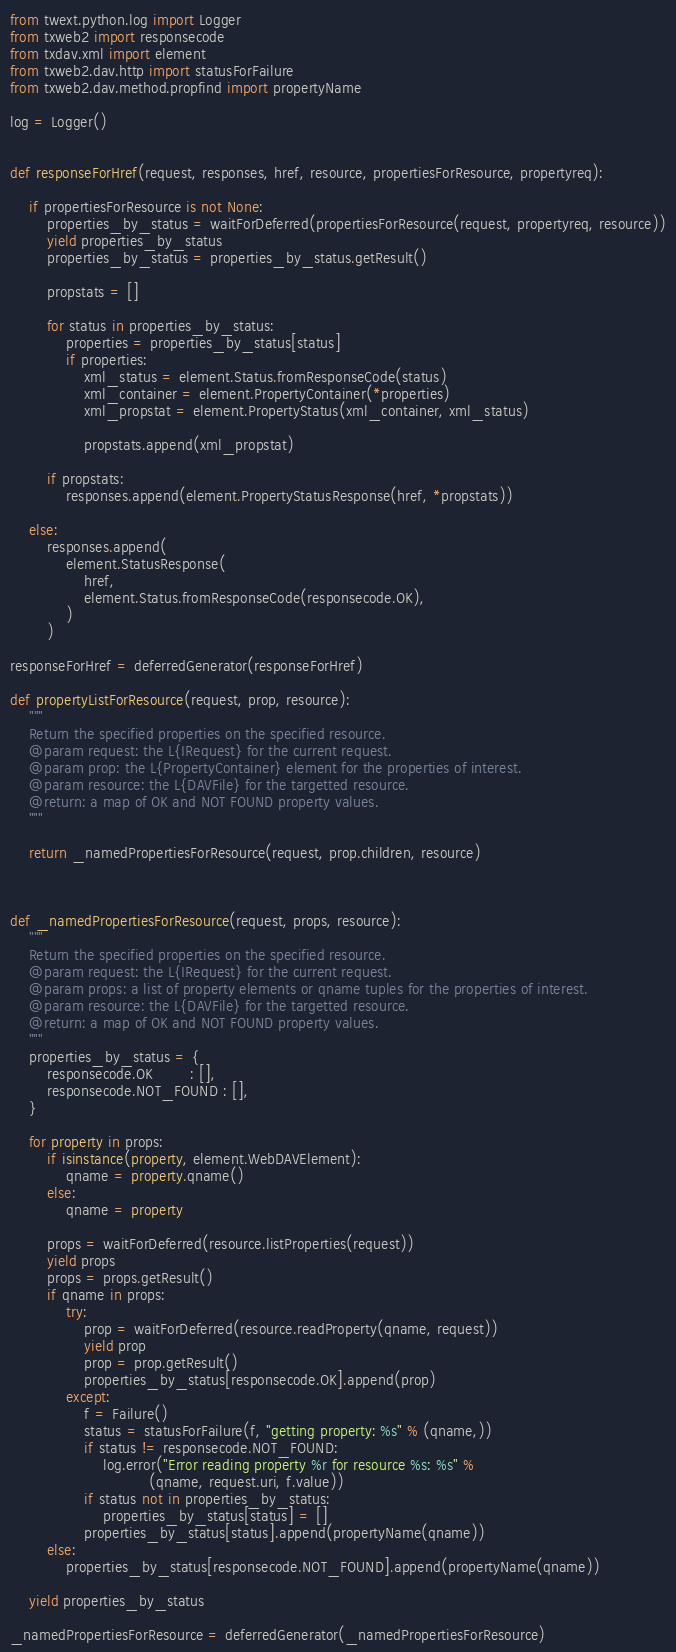<code> <loc_0><loc_0><loc_500><loc_500><_Python_>from twext.python.log import Logger
from txweb2 import responsecode
from txdav.xml import element
from txweb2.dav.http import statusForFailure
from txweb2.dav.method.propfind import propertyName

log = Logger()


def responseForHref(request, responses, href, resource, propertiesForResource, propertyreq):

    if propertiesForResource is not None:
        properties_by_status = waitForDeferred(propertiesForResource(request, propertyreq, resource))
        yield properties_by_status
        properties_by_status = properties_by_status.getResult()

        propstats = []

        for status in properties_by_status:
            properties = properties_by_status[status]
            if properties:
                xml_status = element.Status.fromResponseCode(status)
                xml_container = element.PropertyContainer(*properties)
                xml_propstat = element.PropertyStatus(xml_container, xml_status)

                propstats.append(xml_propstat)

        if propstats:
            responses.append(element.PropertyStatusResponse(href, *propstats))

    else:
        responses.append(
            element.StatusResponse(
                href,
                element.Status.fromResponseCode(responsecode.OK),
            )
        )

responseForHref = deferredGenerator(responseForHref)

def propertyListForResource(request, prop, resource):
    """
    Return the specified properties on the specified resource.
    @param request: the L{IRequest} for the current request.
    @param prop: the L{PropertyContainer} element for the properties of interest.
    @param resource: the L{DAVFile} for the targetted resource.
    @return: a map of OK and NOT FOUND property values.
    """

    return _namedPropertiesForResource(request, prop.children, resource)



def _namedPropertiesForResource(request, props, resource):
    """
    Return the specified properties on the specified resource.
    @param request: the L{IRequest} for the current request.
    @param props: a list of property elements or qname tuples for the properties of interest.
    @param resource: the L{DAVFile} for the targetted resource.
    @return: a map of OK and NOT FOUND property values.
    """
    properties_by_status = {
        responsecode.OK        : [],
        responsecode.NOT_FOUND : [],
    }

    for property in props:
        if isinstance(property, element.WebDAVElement):
            qname = property.qname()
        else:
            qname = property

        props = waitForDeferred(resource.listProperties(request))
        yield props
        props = props.getResult()
        if qname in props:
            try:
                prop = waitForDeferred(resource.readProperty(qname, request))
                yield prop
                prop = prop.getResult()
                properties_by_status[responsecode.OK].append(prop)
            except:
                f = Failure()
                status = statusForFailure(f, "getting property: %s" % (qname,))
                if status != responsecode.NOT_FOUND:
                    log.error("Error reading property %r for resource %s: %s" %
                              (qname, request.uri, f.value))
                if status not in properties_by_status:
                    properties_by_status[status] = []
                properties_by_status[status].append(propertyName(qname))
        else:
            properties_by_status[responsecode.NOT_FOUND].append(propertyName(qname))

    yield properties_by_status

_namedPropertiesForResource = deferredGenerator(_namedPropertiesForResource)
</code> 